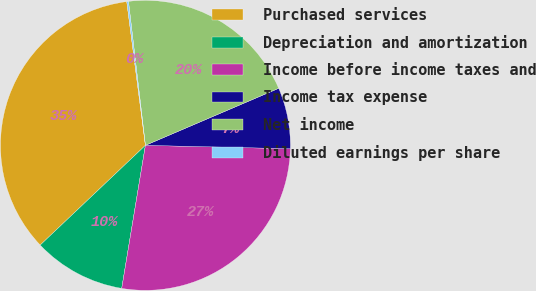<chart> <loc_0><loc_0><loc_500><loc_500><pie_chart><fcel>Purchased services<fcel>Depreciation and amortization<fcel>Income before income taxes and<fcel>Income tax expense<fcel>Net income<fcel>Diluted earnings per share<nl><fcel>35.02%<fcel>10.31%<fcel>27.24%<fcel>6.81%<fcel>20.43%<fcel>0.19%<nl></chart> 